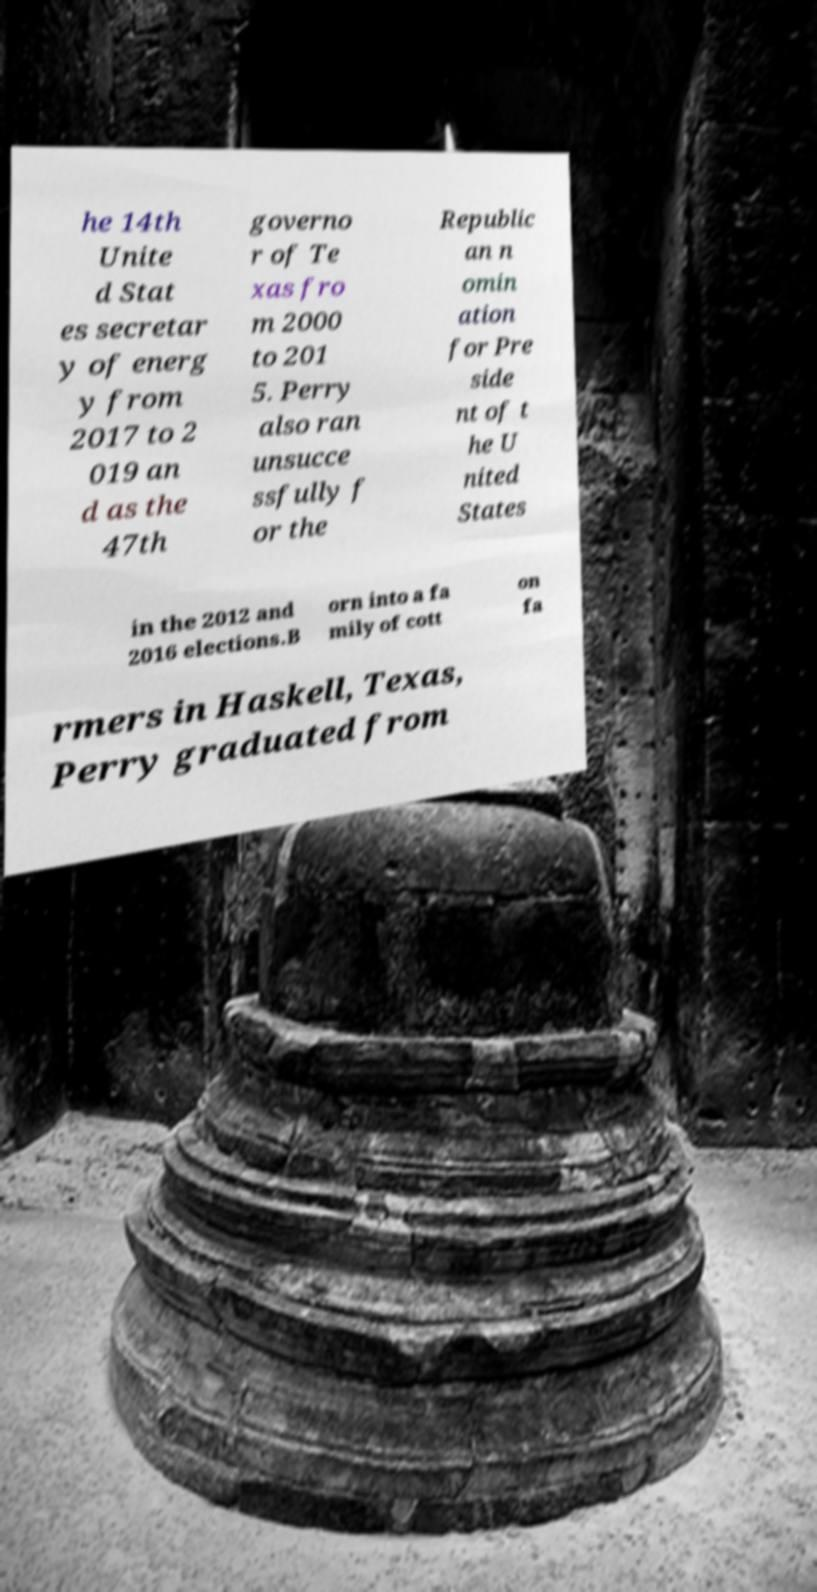For documentation purposes, I need the text within this image transcribed. Could you provide that? he 14th Unite d Stat es secretar y of energ y from 2017 to 2 019 an d as the 47th governo r of Te xas fro m 2000 to 201 5. Perry also ran unsucce ssfully f or the Republic an n omin ation for Pre side nt of t he U nited States in the 2012 and 2016 elections.B orn into a fa mily of cott on fa rmers in Haskell, Texas, Perry graduated from 